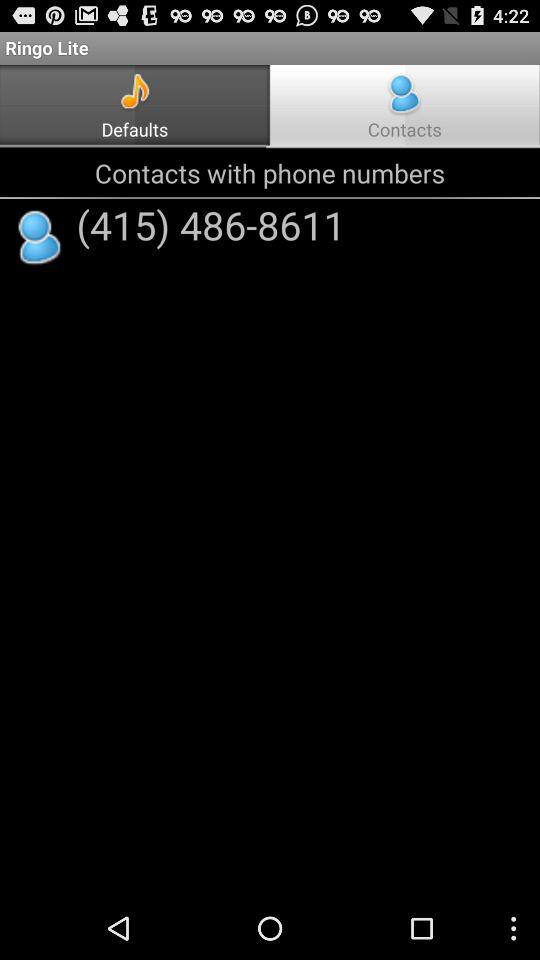What is the application name? The application name is "Ringo Lite". 